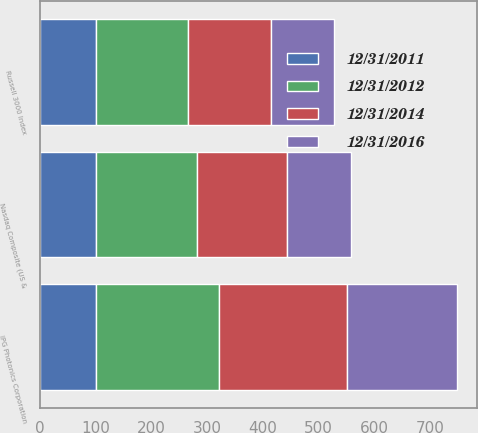Convert chart to OTSL. <chart><loc_0><loc_0><loc_500><loc_500><stacked_bar_chart><ecel><fcel>IPG Photonics Corporation<fcel>Nasdaq Composite (US &<fcel>Russell 3000 Index<nl><fcel>12/31/2011<fcel>100<fcel>100<fcel>100<nl><fcel>12/31/2016<fcel>196.78<fcel>115.91<fcel>113.98<nl><fcel>12/31/2014<fcel>229.14<fcel>160.32<fcel>149.25<nl><fcel>12/31/2012<fcel>221.2<fcel>181.8<fcel>164.85<nl></chart> 